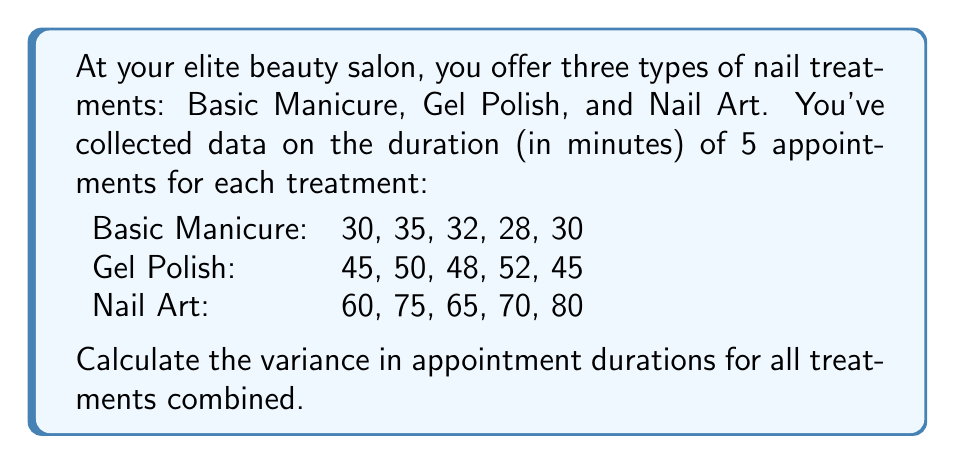Teach me how to tackle this problem. To calculate the variance, we'll follow these steps:

1. Calculate the mean duration for all appointments:
   $$\mu = \frac{30+35+32+28+30+45+50+48+52+45+60+75+65+70+80}{15} = 49.67$$

2. Calculate the squared differences from the mean for each appointment:
   $$(30-49.67)^2, (35-49.67)^2, ..., (80-49.67)^2$$

3. Sum up all the squared differences:
   $$\sum_{i=1}^{15} (x_i - \mu)^2 = 386.89 + 215.11 + ... + 920.11 = 8,204.67$$

4. Divide the sum by the number of appointments (15) to get the variance:
   $$\text{Variance} = \frac{\sum_{i=1}^{15} (x_i - \mu)^2}{15} = \frac{8,204.67}{15} = 546.98$$

Therefore, the variance in appointment durations for all treatments combined is approximately 546.98 square minutes.
Answer: 546.98 square minutes 